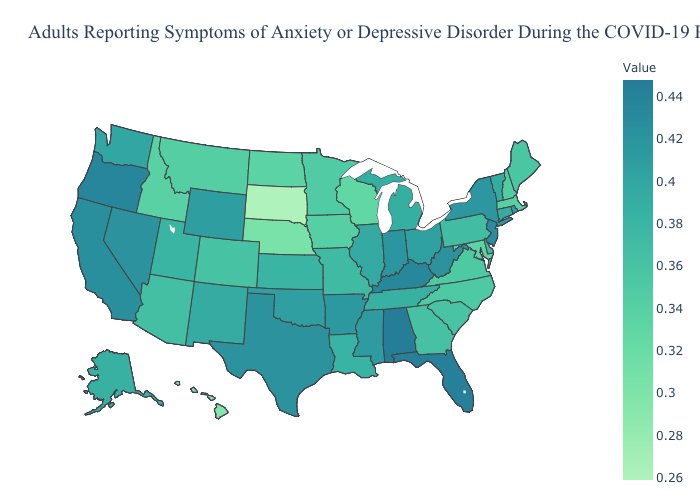Does Louisiana have a higher value than North Carolina?
Short answer required. Yes. Does the map have missing data?
Quick response, please. No. Among the states that border Nevada , which have the highest value?
Short answer required. Oregon. Does New Jersey have the highest value in the Northeast?
Answer briefly. Yes. Does New Jersey have a higher value than Alabama?
Answer briefly. No. Is the legend a continuous bar?
Quick response, please. Yes. Does Michigan have a lower value than Georgia?
Short answer required. No. Among the states that border West Virginia , which have the highest value?
Quick response, please. Kentucky. 